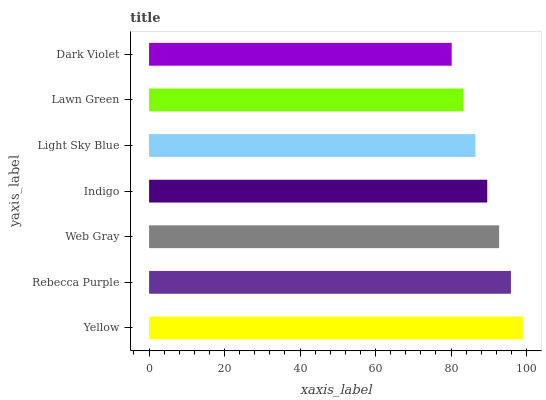Is Dark Violet the minimum?
Answer yes or no. Yes. Is Yellow the maximum?
Answer yes or no. Yes. Is Rebecca Purple the minimum?
Answer yes or no. No. Is Rebecca Purple the maximum?
Answer yes or no. No. Is Yellow greater than Rebecca Purple?
Answer yes or no. Yes. Is Rebecca Purple less than Yellow?
Answer yes or no. Yes. Is Rebecca Purple greater than Yellow?
Answer yes or no. No. Is Yellow less than Rebecca Purple?
Answer yes or no. No. Is Indigo the high median?
Answer yes or no. Yes. Is Indigo the low median?
Answer yes or no. Yes. Is Lawn Green the high median?
Answer yes or no. No. Is Rebecca Purple the low median?
Answer yes or no. No. 